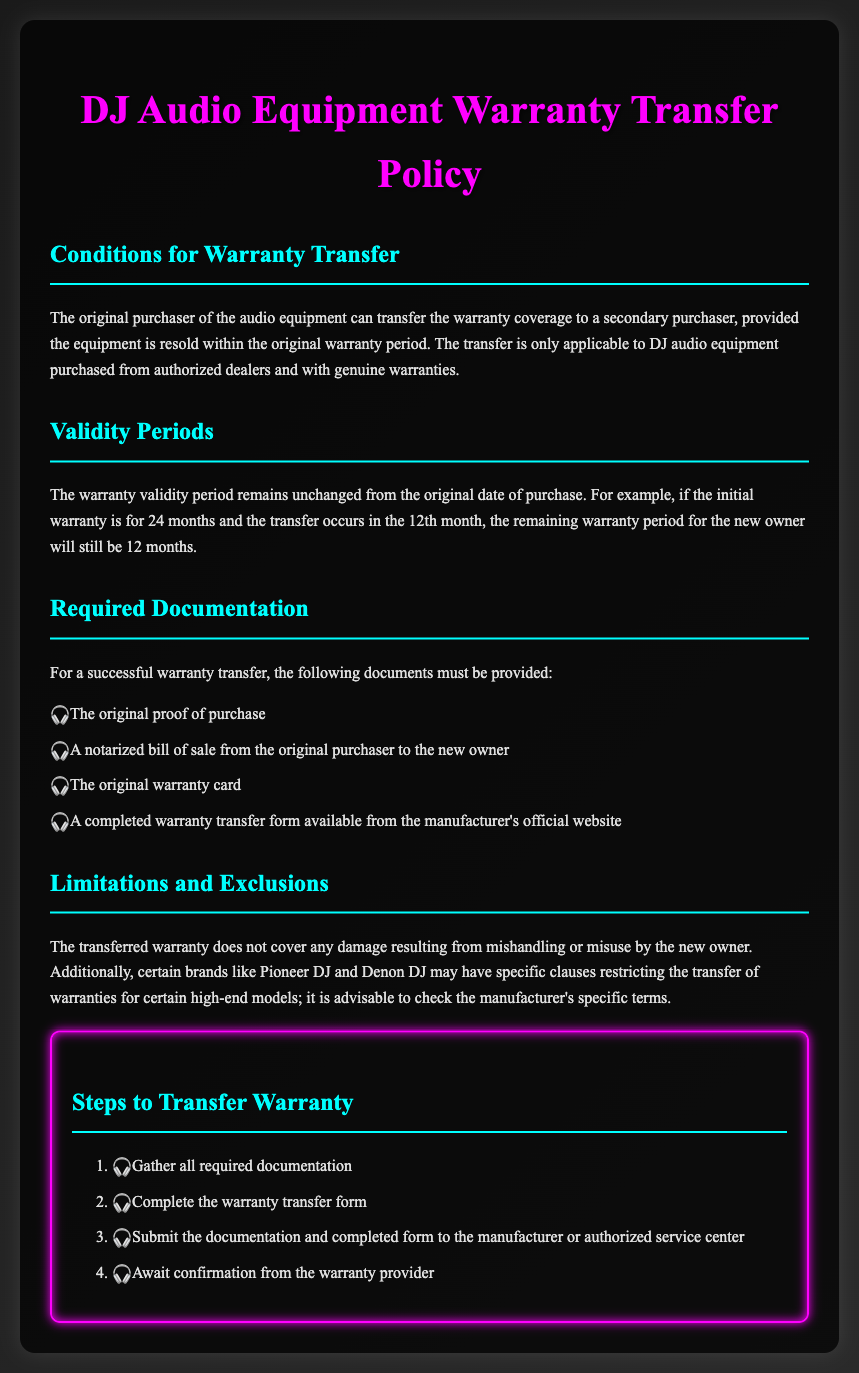What is required for warranty transfer? The document lists specific documents that must be provided for a successful warranty transfer.
Answer: Original proof of purchase, notarized bill of sale, original warranty card, completed warranty transfer form How long is the warranty validity period for audio equipment? The warranty validity period depends on the original date of purchase and remains unchanged after transfer.
Answer: Unchanged What must be completed for the warranty transfer? The winner of the transfer needs to fill out a particular form.
Answer: Warranty transfer form What type of equipment does the warranty transfer policy apply to? The policy specifically mentions the types of equipment it pertains to.
Answer: DJ audio equipment What may restrict the warranty transfer for specific brands? The document mentions that certain brands could have specific clauses that impact transfers.
Answer: Brand-specific clauses How many steps are there to transfer the warranty? The document outlines the number of steps involved in the process of transferring the warranty.
Answer: Four steps What documentation is related to the original purchaser? The document notes the necessity of a specific document related to the act of selling.
Answer: Notarized bill of sale What is excluded from the transferred warranty coverage? The document specifies what types of damage or issues will not be covered after the transfer.
Answer: Damage from mishandling or misuse 